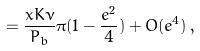<formula> <loc_0><loc_0><loc_500><loc_500>= \frac { x K \nu } { P _ { b } } \pi ( 1 - \frac { e ^ { 2 } } { 4 } ) + O ( e ^ { 4 } ) \, ,</formula> 